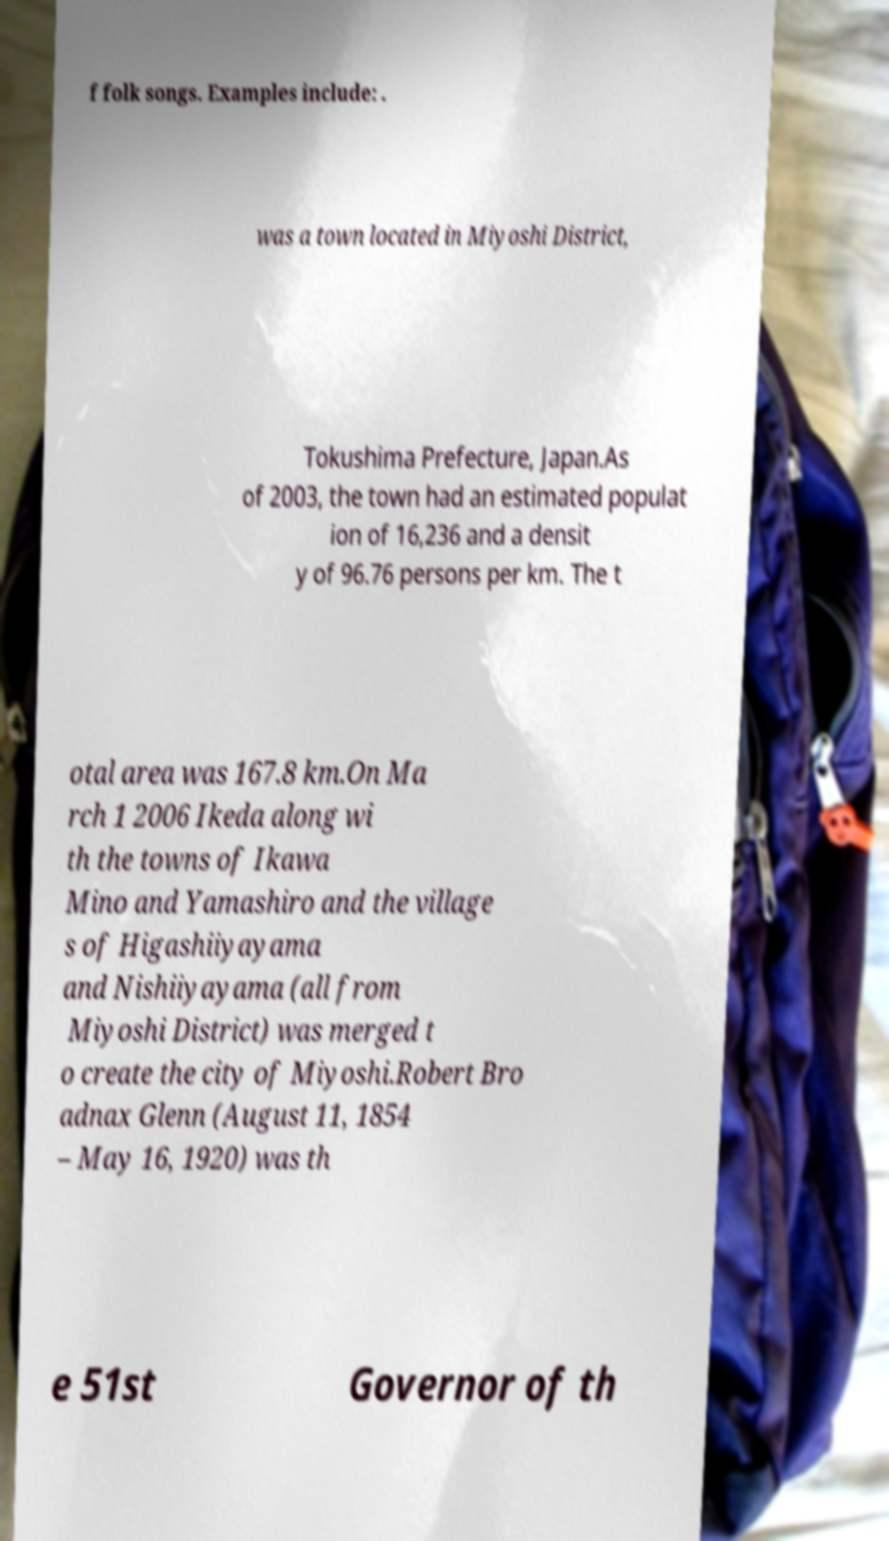Could you extract and type out the text from this image? f folk songs. Examples include: . was a town located in Miyoshi District, Tokushima Prefecture, Japan.As of 2003, the town had an estimated populat ion of 16,236 and a densit y of 96.76 persons per km. The t otal area was 167.8 km.On Ma rch 1 2006 Ikeda along wi th the towns of Ikawa Mino and Yamashiro and the village s of Higashiiyayama and Nishiiyayama (all from Miyoshi District) was merged t o create the city of Miyoshi.Robert Bro adnax Glenn (August 11, 1854 – May 16, 1920) was th e 51st Governor of th 